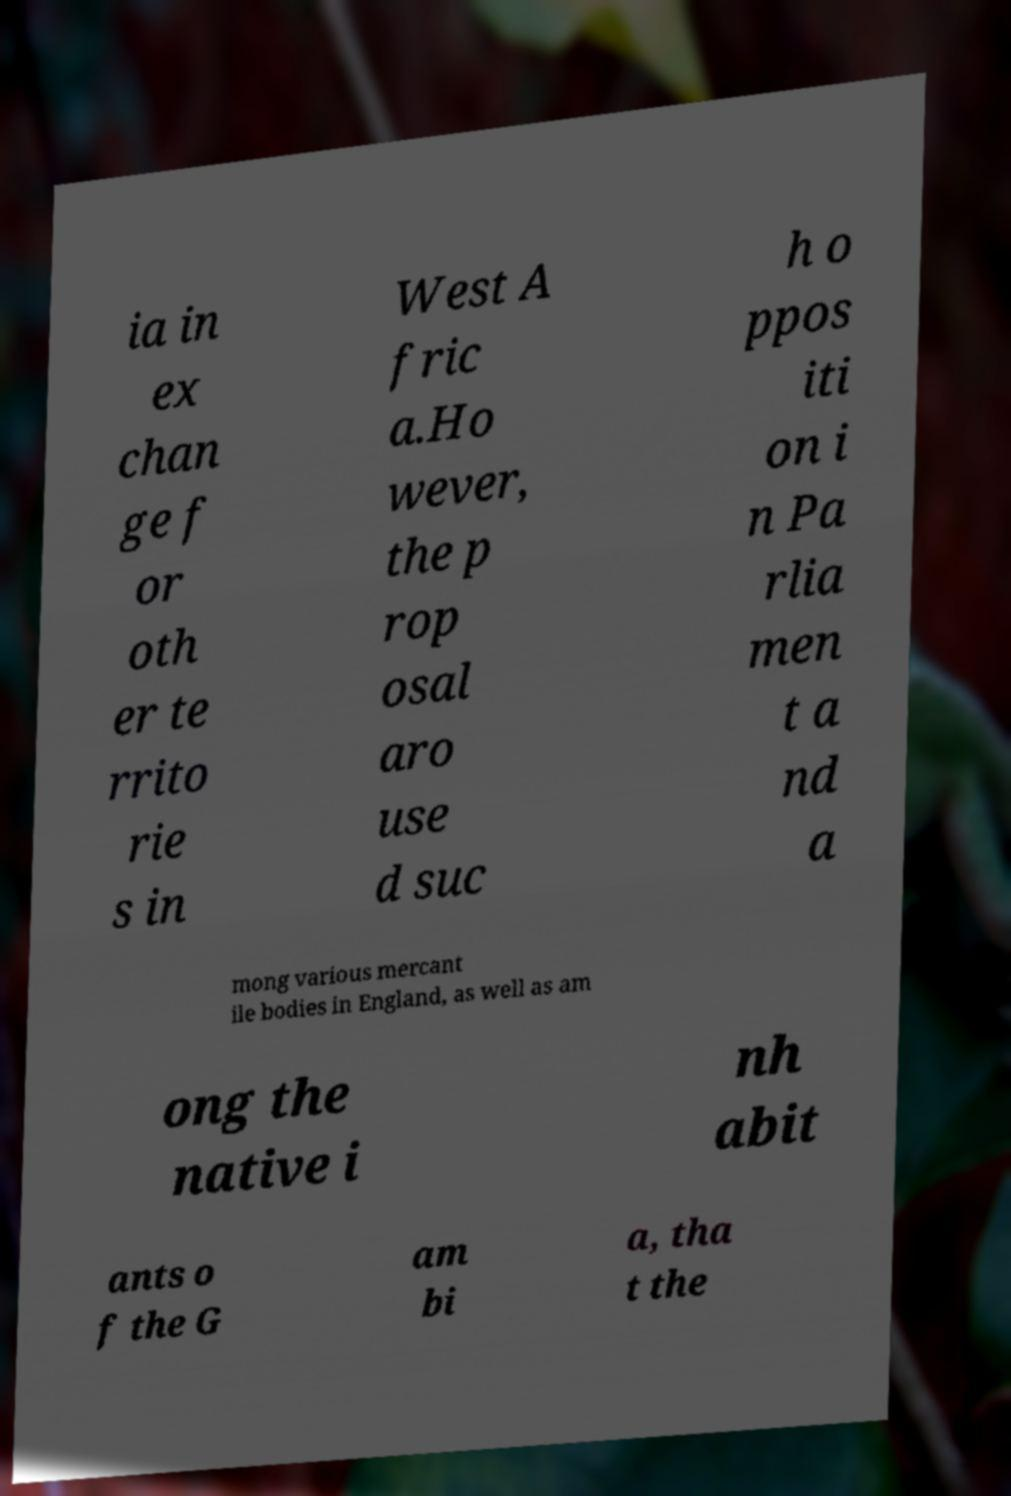What messages or text are displayed in this image? I need them in a readable, typed format. ia in ex chan ge f or oth er te rrito rie s in West A fric a.Ho wever, the p rop osal aro use d suc h o ppos iti on i n Pa rlia men t a nd a mong various mercant ile bodies in England, as well as am ong the native i nh abit ants o f the G am bi a, tha t the 